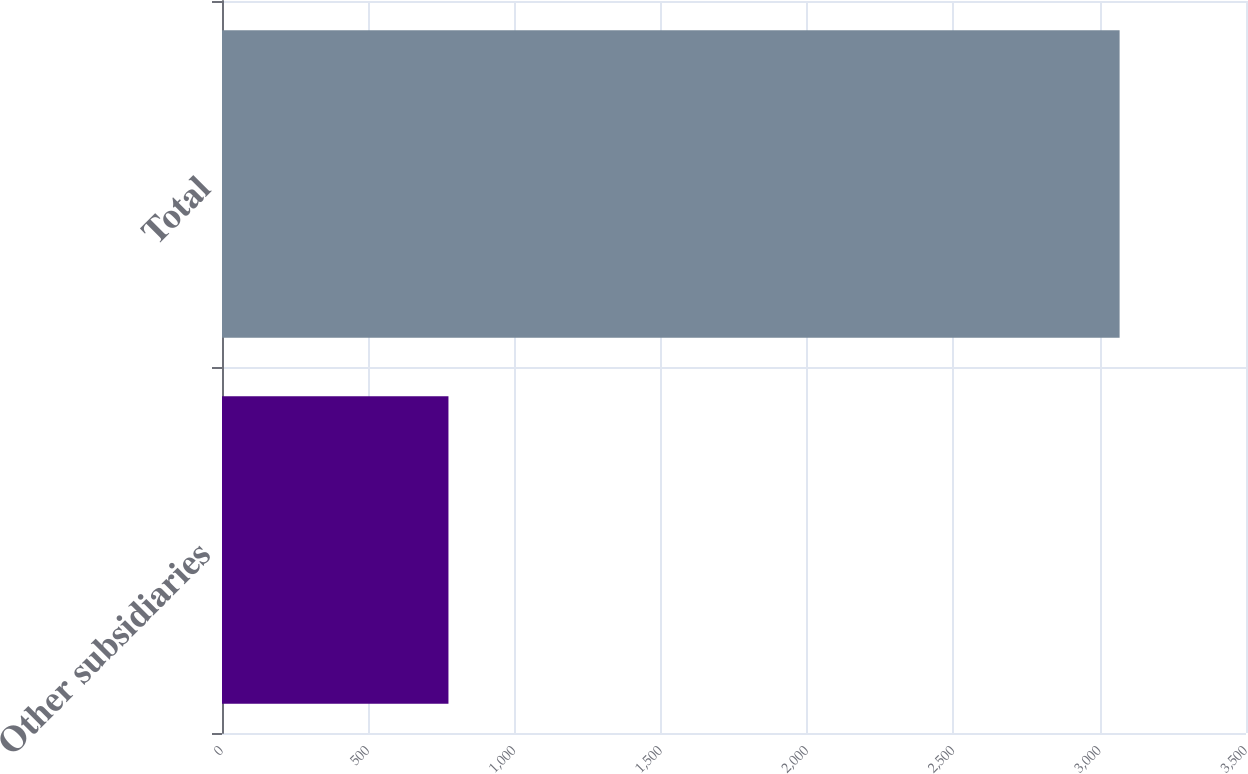<chart> <loc_0><loc_0><loc_500><loc_500><bar_chart><fcel>Other subsidiaries<fcel>Total<nl><fcel>774<fcel>3068<nl></chart> 